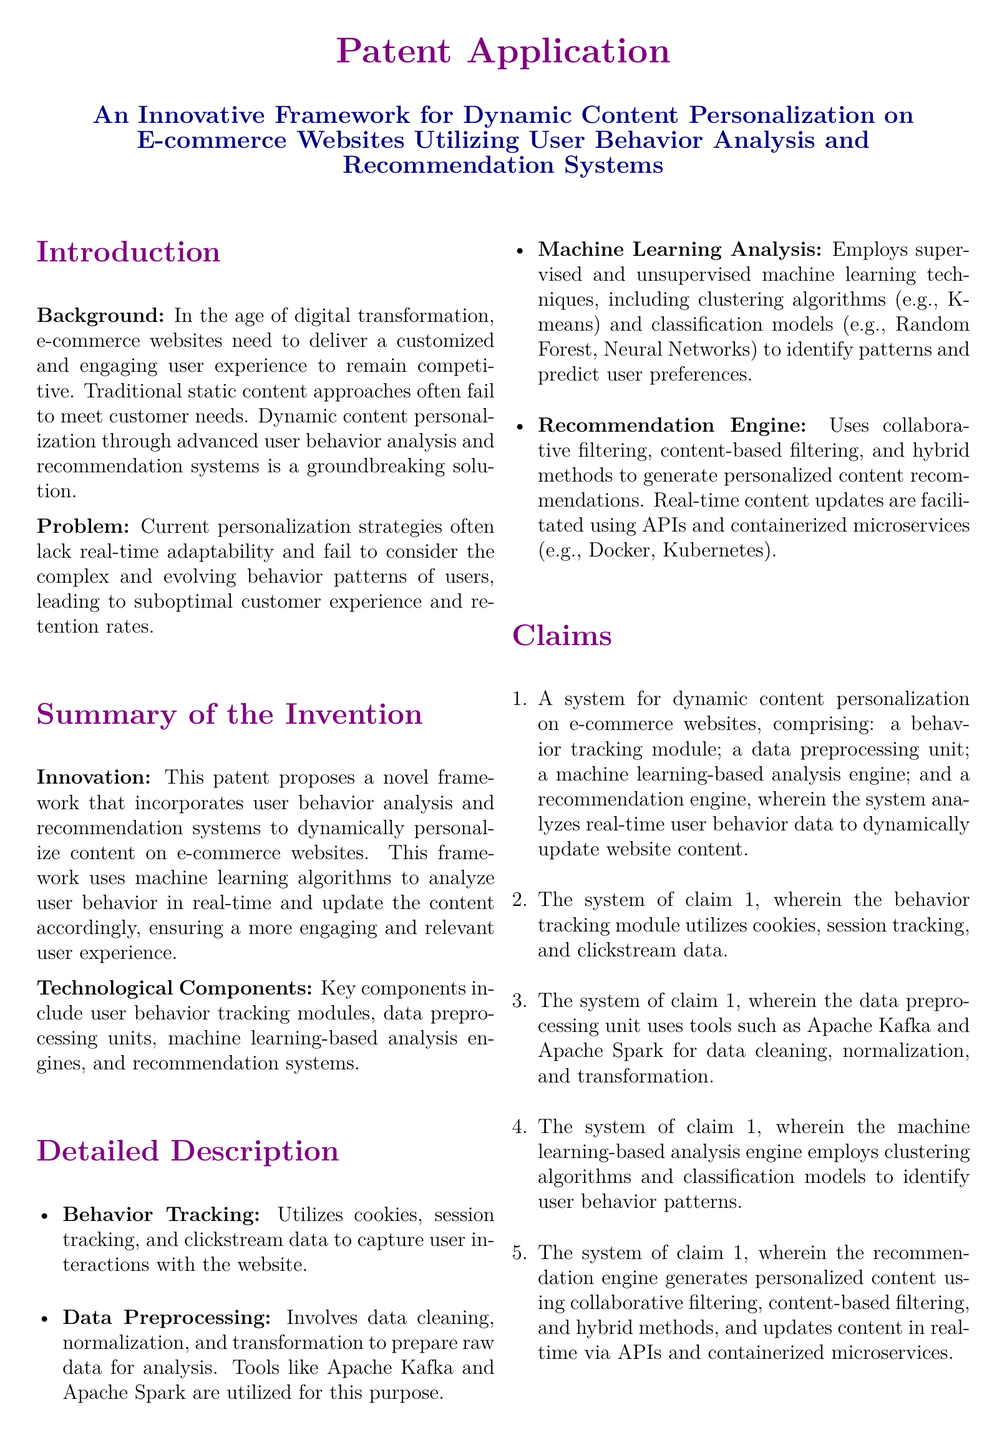What is the main innovation proposed in the patent? The main innovation is a novel framework that incorporates user behavior analysis and recommendation systems to dynamically personalize content on e-commerce websites.
Answer: Dynamic content personalization What technologies are used in data preprocessing? The document mentions that the data preprocessing unit uses tools like Apache Kafka and Apache Spark for data cleaning, normalization, and transformation.
Answer: Apache Kafka and Apache Spark What type of algorithms are employed for machine learning analysis? The document states that it employs supervised and unsupervised machine learning techniques, including clustering algorithms and classification models.
Answer: Clustering and classification Which component captures user interactions? The behavior tracking module is responsible for capturing user interactions with the website.
Answer: Behavior tracking module How does the recommendation engine generate personalized content? The document outlines that the recommendation engine uses collaborative filtering, content-based filtering, and hybrid methods to generate personalized content recommendations.
Answer: Collaborative filtering, content-based filtering, hybrid methods What is the purpose of the proposed system? The proposed system analyzes real-time user behavior data to dynamically update website content.
Answer: Dynamically update website content What is a key benefit of this framework? The framework improves user satisfaction and increases conversion rates by providing a tailored user experience.
Answer: Improves user satisfaction What does the framework aim to address in e-commerce? The framework aims to address the lack of real-time adaptability in current personalization strategies.
Answer: Real-time adaptability 